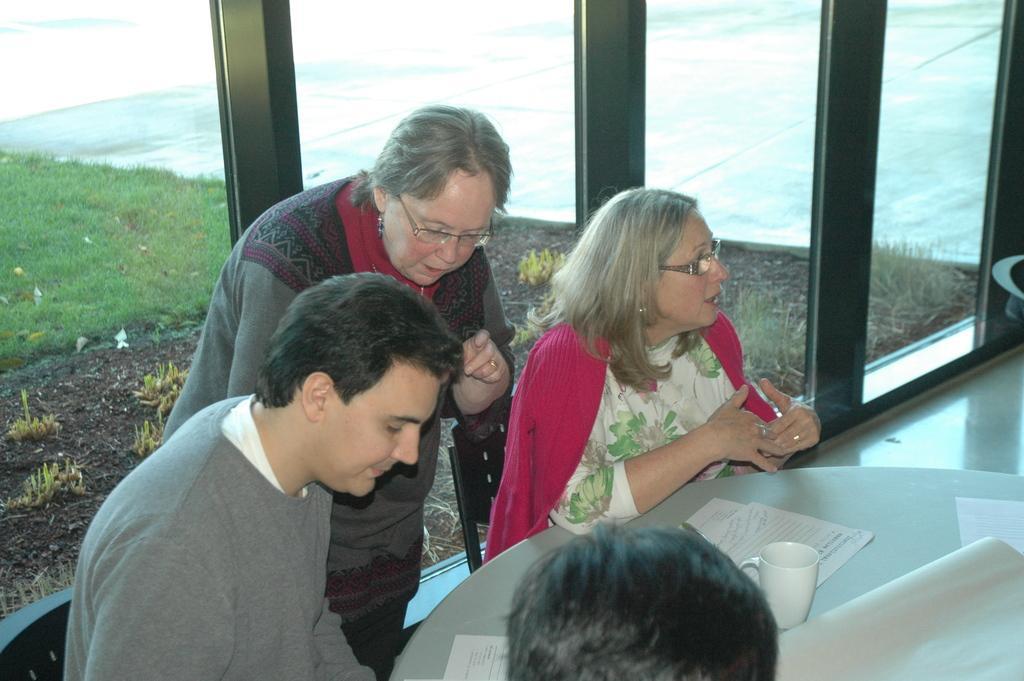Could you give a brief overview of what you see in this image? In this image we can see people sitting on chairs. There is a table on which there are papers and mug. There is a lady standing in the background of the image. In the background of the image there is a glass wall through which we can see grass and plants. 